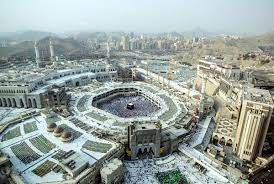Can you describe the significance of the black cube-shaped structure at the center? The black cube-shaped structure at the center is the Kaaba, which is regarded as the most sacred site in Islam. It is located within the Masjid al-Haram in Mecca, Saudi Arabia. Muslims around the world face the Kaaba during their prayers, a direction known as the Qibla. The Kaaba is built of granite, and its corners roughly align with the cardinal directions. The structure is draped in a silk and cotton veil known as the Kiswah. During the Hajj pilgrimage, millions of Muslims visit the Kaaba, performing Tawaf by walking around it seven times in a counterclockwise direction. What is the history behind the construction of the Great Mosque of Mecca? The Great Mosque of Mecca, also known as Masjid al-Haram, has a rich history that dates back several millennia. According to Islamic tradition, the original structure of the Kaaba was built by the prophet Ibrahim (Abraham) and his son Ismail (Ishmael) over 4,000 years ago. The surrounding mosque has undergone numerous renovations and expansions throughout history. The first major reconstruction occurred in the 7th century under the rule of the Caliph Omar ibn al-Khattab. Over the centuries, subsequent rulers, including the Abbasid, Ottoman, and modern Saudi dynasties, have expanded and enhanced the mosque to accommodate the growing number of pilgrims. Today, it is the largest mosque in the world, with a capacity to hold millions of worshippers, especially during the annual Hajj pilgrimage. Why does the image capture the scene from a high angle? The high-angle perspective provides a comprehensive and striking view of the Great Mosque of Mecca, allowing viewers to appreciate its vast scale and architectural details. This viewpoint emphasizes the central importance of the Kaaba and provides context by showing the surrounding cityscape and natural landscape. The high angle also creates a sense of grandeur and depth, highlighting the mosque's significance within both the urban environment and the spiritual lives of millions of Muslims around the world. 